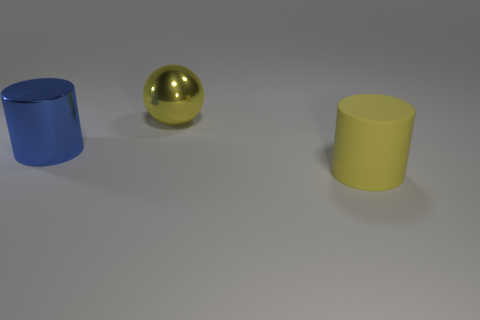Add 3 purple matte cylinders. How many objects exist? 6 Subtract all balls. How many objects are left? 2 Subtract all large yellow cylinders. Subtract all large blue metal cylinders. How many objects are left? 1 Add 1 yellow matte cylinders. How many yellow matte cylinders are left? 2 Add 3 metal things. How many metal things exist? 5 Subtract 0 green balls. How many objects are left? 3 